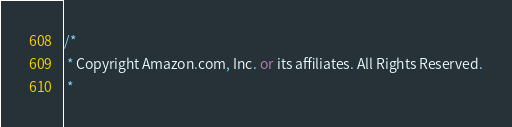<code> <loc_0><loc_0><loc_500><loc_500><_C#_>/*
 * Copyright Amazon.com, Inc. or its affiliates. All Rights Reserved.
 * </code> 